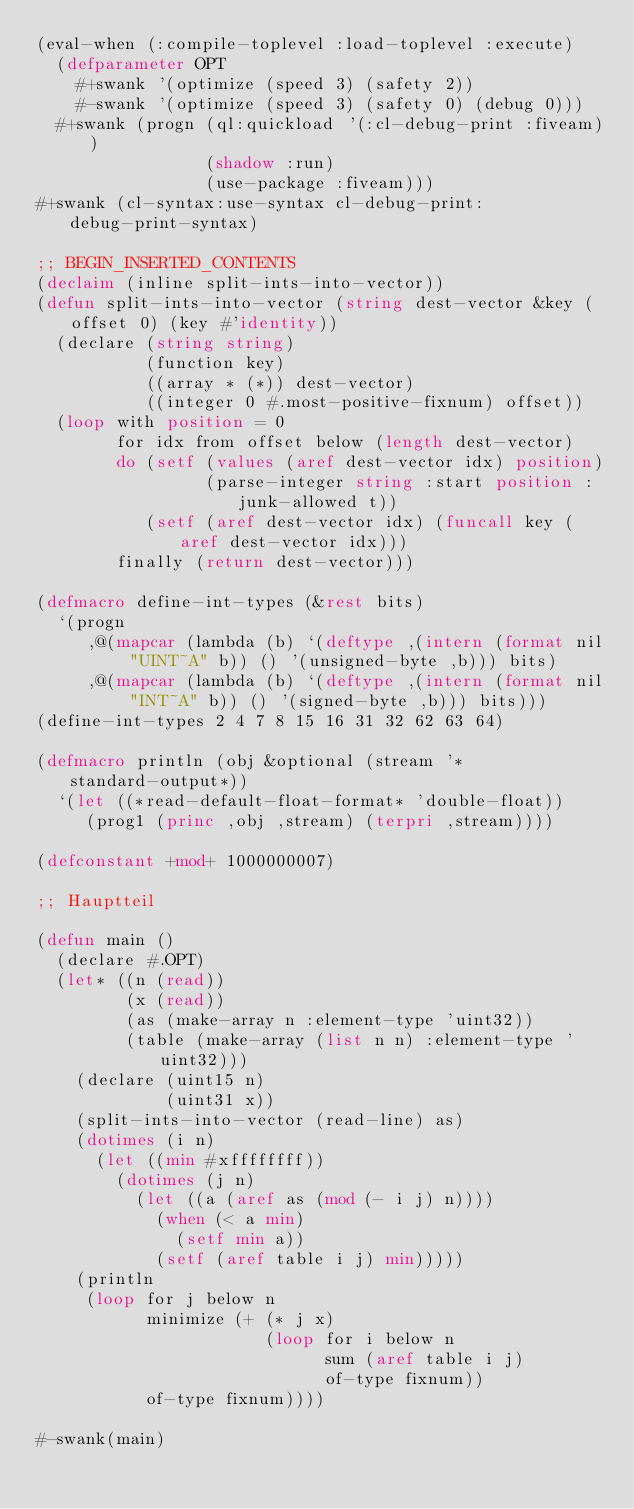Convert code to text. <code><loc_0><loc_0><loc_500><loc_500><_Lisp_>(eval-when (:compile-toplevel :load-toplevel :execute)
  (defparameter OPT
    #+swank '(optimize (speed 3) (safety 2))
    #-swank '(optimize (speed 3) (safety 0) (debug 0)))
  #+swank (progn (ql:quickload '(:cl-debug-print :fiveam))
                 (shadow :run)
                 (use-package :fiveam)))
#+swank (cl-syntax:use-syntax cl-debug-print:debug-print-syntax)

;; BEGIN_INSERTED_CONTENTS
(declaim (inline split-ints-into-vector))
(defun split-ints-into-vector (string dest-vector &key (offset 0) (key #'identity))
  (declare (string string)
           (function key)
           ((array * (*)) dest-vector)
           ((integer 0 #.most-positive-fixnum) offset))
  (loop with position = 0
        for idx from offset below (length dest-vector)
        do (setf (values (aref dest-vector idx) position)
                 (parse-integer string :start position :junk-allowed t))
           (setf (aref dest-vector idx) (funcall key (aref dest-vector idx)))
        finally (return dest-vector)))

(defmacro define-int-types (&rest bits)
  `(progn
     ,@(mapcar (lambda (b) `(deftype ,(intern (format nil "UINT~A" b)) () '(unsigned-byte ,b))) bits)
     ,@(mapcar (lambda (b) `(deftype ,(intern (format nil "INT~A" b)) () '(signed-byte ,b))) bits)))
(define-int-types 2 4 7 8 15 16 31 32 62 63 64)

(defmacro println (obj &optional (stream '*standard-output*))
  `(let ((*read-default-float-format* 'double-float))
     (prog1 (princ ,obj ,stream) (terpri ,stream))))

(defconstant +mod+ 1000000007)

;; Hauptteil

(defun main ()
  (declare #.OPT)
  (let* ((n (read))
         (x (read))
         (as (make-array n :element-type 'uint32))
         (table (make-array (list n n) :element-type 'uint32)))
    (declare (uint15 n)
             (uint31 x))
    (split-ints-into-vector (read-line) as)
    (dotimes (i n)
      (let ((min #xffffffff))
        (dotimes (j n)
          (let ((a (aref as (mod (- i j) n))))
            (when (< a min)
              (setf min a))
            (setf (aref table i j) min)))))
    (println
     (loop for j below n
           minimize (+ (* j x)
                       (loop for i below n
                             sum (aref table i j)
                             of-type fixnum))
           of-type fixnum))))

#-swank(main)
</code> 